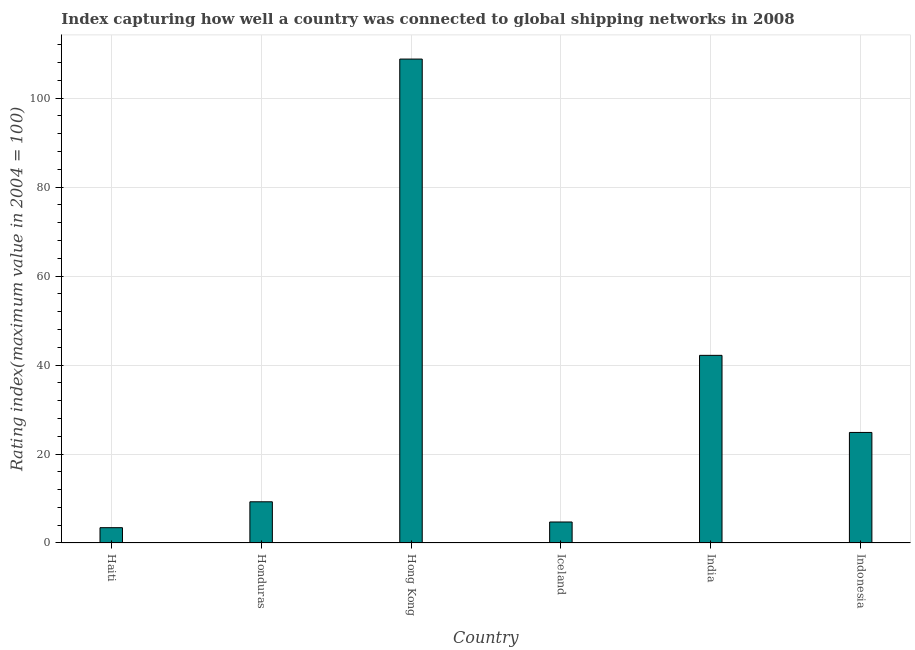Does the graph contain any zero values?
Ensure brevity in your answer.  No. Does the graph contain grids?
Your answer should be compact. Yes. What is the title of the graph?
Ensure brevity in your answer.  Index capturing how well a country was connected to global shipping networks in 2008. What is the label or title of the X-axis?
Offer a terse response. Country. What is the label or title of the Y-axis?
Keep it short and to the point. Rating index(maximum value in 2004 = 100). What is the liner shipping connectivity index in Hong Kong?
Keep it short and to the point. 108.78. Across all countries, what is the maximum liner shipping connectivity index?
Your response must be concise. 108.78. Across all countries, what is the minimum liner shipping connectivity index?
Your answer should be very brief. 3.44. In which country was the liner shipping connectivity index maximum?
Make the answer very short. Hong Kong. In which country was the liner shipping connectivity index minimum?
Your answer should be very brief. Haiti. What is the sum of the liner shipping connectivity index?
Your answer should be very brief. 193.23. What is the difference between the liner shipping connectivity index in Honduras and Hong Kong?
Your answer should be very brief. -99.52. What is the average liner shipping connectivity index per country?
Ensure brevity in your answer.  32.2. What is the median liner shipping connectivity index?
Your answer should be compact. 17.05. What is the ratio of the liner shipping connectivity index in Iceland to that in Indonesia?
Provide a short and direct response. 0.19. What is the difference between the highest and the second highest liner shipping connectivity index?
Offer a terse response. 66.6. What is the difference between the highest and the lowest liner shipping connectivity index?
Provide a short and direct response. 105.34. Are all the bars in the graph horizontal?
Your response must be concise. No. How many countries are there in the graph?
Give a very brief answer. 6. What is the difference between two consecutive major ticks on the Y-axis?
Give a very brief answer. 20. What is the Rating index(maximum value in 2004 = 100) of Haiti?
Make the answer very short. 3.44. What is the Rating index(maximum value in 2004 = 100) in Honduras?
Provide a succinct answer. 9.26. What is the Rating index(maximum value in 2004 = 100) in Hong Kong?
Your answer should be compact. 108.78. What is the Rating index(maximum value in 2004 = 100) of Iceland?
Keep it short and to the point. 4.72. What is the Rating index(maximum value in 2004 = 100) in India?
Your response must be concise. 42.18. What is the Rating index(maximum value in 2004 = 100) in Indonesia?
Your answer should be very brief. 24.85. What is the difference between the Rating index(maximum value in 2004 = 100) in Haiti and Honduras?
Ensure brevity in your answer.  -5.82. What is the difference between the Rating index(maximum value in 2004 = 100) in Haiti and Hong Kong?
Provide a succinct answer. -105.34. What is the difference between the Rating index(maximum value in 2004 = 100) in Haiti and Iceland?
Offer a terse response. -1.28. What is the difference between the Rating index(maximum value in 2004 = 100) in Haiti and India?
Provide a short and direct response. -38.74. What is the difference between the Rating index(maximum value in 2004 = 100) in Haiti and Indonesia?
Ensure brevity in your answer.  -21.41. What is the difference between the Rating index(maximum value in 2004 = 100) in Honduras and Hong Kong?
Give a very brief answer. -99.52. What is the difference between the Rating index(maximum value in 2004 = 100) in Honduras and Iceland?
Offer a terse response. 4.54. What is the difference between the Rating index(maximum value in 2004 = 100) in Honduras and India?
Ensure brevity in your answer.  -32.92. What is the difference between the Rating index(maximum value in 2004 = 100) in Honduras and Indonesia?
Make the answer very short. -15.59. What is the difference between the Rating index(maximum value in 2004 = 100) in Hong Kong and Iceland?
Give a very brief answer. 104.06. What is the difference between the Rating index(maximum value in 2004 = 100) in Hong Kong and India?
Your answer should be compact. 66.6. What is the difference between the Rating index(maximum value in 2004 = 100) in Hong Kong and Indonesia?
Give a very brief answer. 83.93. What is the difference between the Rating index(maximum value in 2004 = 100) in Iceland and India?
Provide a short and direct response. -37.46. What is the difference between the Rating index(maximum value in 2004 = 100) in Iceland and Indonesia?
Keep it short and to the point. -20.13. What is the difference between the Rating index(maximum value in 2004 = 100) in India and Indonesia?
Your answer should be very brief. 17.33. What is the ratio of the Rating index(maximum value in 2004 = 100) in Haiti to that in Honduras?
Your answer should be compact. 0.37. What is the ratio of the Rating index(maximum value in 2004 = 100) in Haiti to that in Hong Kong?
Ensure brevity in your answer.  0.03. What is the ratio of the Rating index(maximum value in 2004 = 100) in Haiti to that in Iceland?
Give a very brief answer. 0.73. What is the ratio of the Rating index(maximum value in 2004 = 100) in Haiti to that in India?
Give a very brief answer. 0.08. What is the ratio of the Rating index(maximum value in 2004 = 100) in Haiti to that in Indonesia?
Your answer should be compact. 0.14. What is the ratio of the Rating index(maximum value in 2004 = 100) in Honduras to that in Hong Kong?
Your answer should be very brief. 0.09. What is the ratio of the Rating index(maximum value in 2004 = 100) in Honduras to that in Iceland?
Provide a succinct answer. 1.96. What is the ratio of the Rating index(maximum value in 2004 = 100) in Honduras to that in India?
Your answer should be compact. 0.22. What is the ratio of the Rating index(maximum value in 2004 = 100) in Honduras to that in Indonesia?
Make the answer very short. 0.37. What is the ratio of the Rating index(maximum value in 2004 = 100) in Hong Kong to that in Iceland?
Your answer should be compact. 23.05. What is the ratio of the Rating index(maximum value in 2004 = 100) in Hong Kong to that in India?
Your answer should be compact. 2.58. What is the ratio of the Rating index(maximum value in 2004 = 100) in Hong Kong to that in Indonesia?
Provide a succinct answer. 4.38. What is the ratio of the Rating index(maximum value in 2004 = 100) in Iceland to that in India?
Ensure brevity in your answer.  0.11. What is the ratio of the Rating index(maximum value in 2004 = 100) in Iceland to that in Indonesia?
Offer a terse response. 0.19. What is the ratio of the Rating index(maximum value in 2004 = 100) in India to that in Indonesia?
Keep it short and to the point. 1.7. 